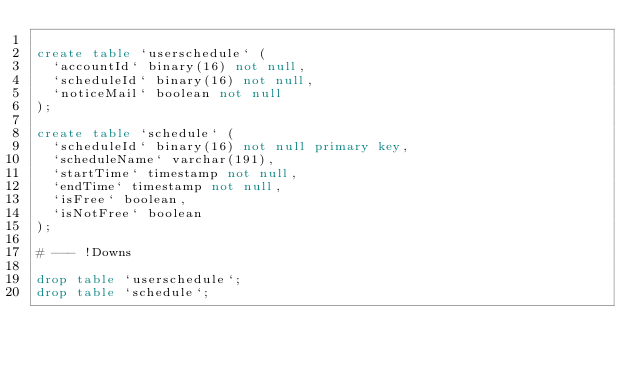<code> <loc_0><loc_0><loc_500><loc_500><_SQL_>
create table `userschedule` (
  `accountId` binary(16) not null,
  `scheduleId` binary(16) not null,
  `noticeMail` boolean not null
);

create table `schedule` (
  `scheduleId` binary(16) not null primary key,
  `scheduleName` varchar(191),
  `startTime` timestamp not null,
  `endTime` timestamp not null,
  `isFree` boolean,
  `isNotFree` boolean
);

# --- !Downs

drop table `userschedule`;
drop table `schedule`;
</code> 